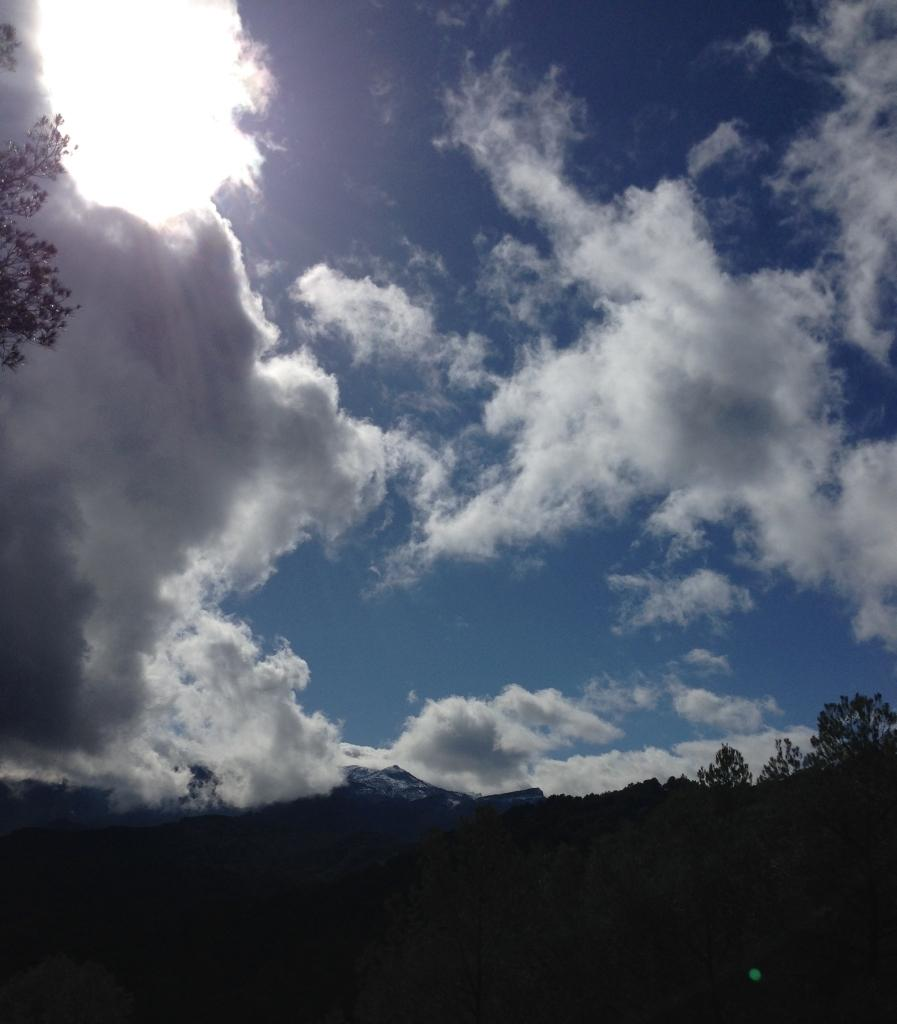What type of landscape is depicted at the bottom of the image? There are hills and trees at the bottom of the image. What can be seen on the ground at the bottom of the image? The ground is visible at the bottom of the image. What is present in the sky at the top of the image? Clouds are present in the sky at the top of the image. What type of roof can be seen on the school in the image? There is no school or roof present in the image. 